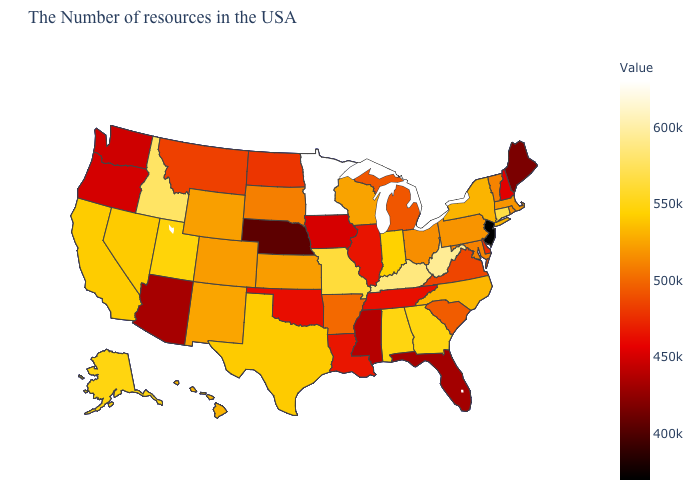Which states hav the highest value in the MidWest?
Answer briefly. Minnesota. Does Connecticut have a lower value than West Virginia?
Short answer required. Yes. Is the legend a continuous bar?
Be succinct. Yes. Among the states that border Minnesota , which have the highest value?
Give a very brief answer. Wisconsin. Which states have the highest value in the USA?
Write a very short answer. Minnesota. Is the legend a continuous bar?
Concise answer only. Yes. Which states have the lowest value in the MidWest?
Answer briefly. Nebraska. Which states have the lowest value in the USA?
Give a very brief answer. New Jersey. 